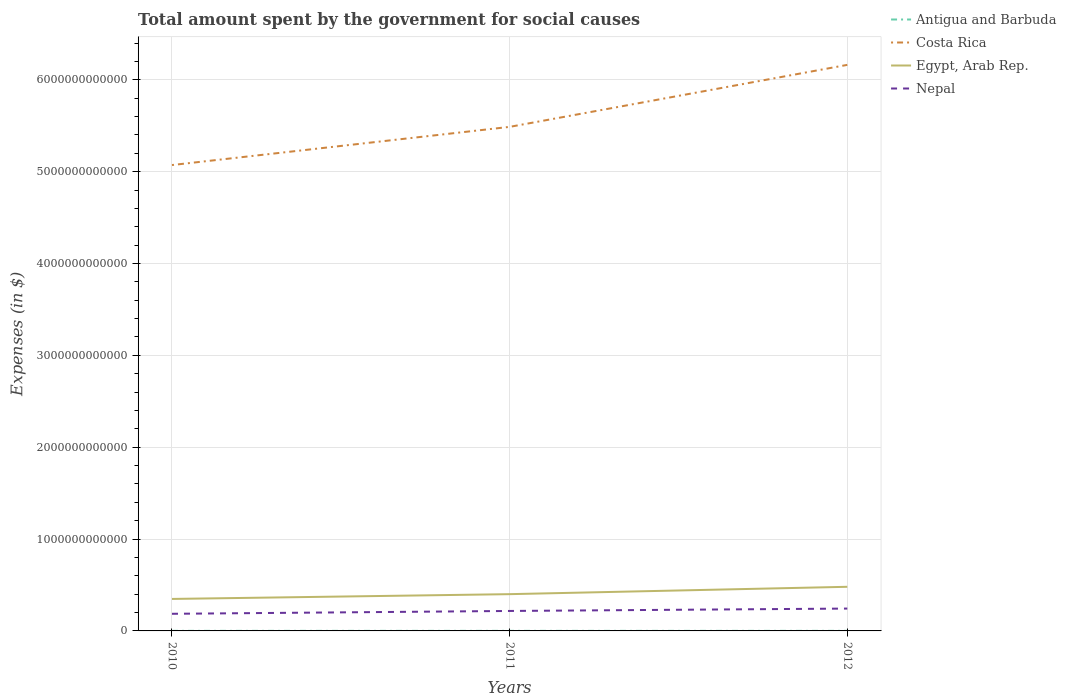Across all years, what is the maximum amount spent for social causes by the government in Antigua and Barbuda?
Provide a short and direct response. 6.72e+08. What is the total amount spent for social causes by the government in Nepal in the graph?
Give a very brief answer. -2.60e+1. What is the difference between the highest and the second highest amount spent for social causes by the government in Nepal?
Ensure brevity in your answer.  5.69e+1. How many lines are there?
Your answer should be compact. 4. How many years are there in the graph?
Provide a succinct answer. 3. What is the difference between two consecutive major ticks on the Y-axis?
Make the answer very short. 1.00e+12. Does the graph contain grids?
Offer a terse response. Yes. Where does the legend appear in the graph?
Keep it short and to the point. Top right. How many legend labels are there?
Offer a terse response. 4. How are the legend labels stacked?
Offer a very short reply. Vertical. What is the title of the graph?
Provide a short and direct response. Total amount spent by the government for social causes. Does "Mauritania" appear as one of the legend labels in the graph?
Ensure brevity in your answer.  No. What is the label or title of the Y-axis?
Keep it short and to the point. Expenses (in $). What is the Expenses (in $) of Antigua and Barbuda in 2010?
Make the answer very short. 6.76e+08. What is the Expenses (in $) in Costa Rica in 2010?
Your response must be concise. 5.07e+12. What is the Expenses (in $) of Egypt, Arab Rep. in 2010?
Provide a succinct answer. 3.48e+11. What is the Expenses (in $) in Nepal in 2010?
Offer a very short reply. 1.86e+11. What is the Expenses (in $) of Antigua and Barbuda in 2011?
Keep it short and to the point. 7.15e+08. What is the Expenses (in $) in Costa Rica in 2011?
Provide a short and direct response. 5.49e+12. What is the Expenses (in $) in Egypt, Arab Rep. in 2011?
Provide a succinct answer. 4.00e+11. What is the Expenses (in $) of Nepal in 2011?
Offer a terse response. 2.17e+11. What is the Expenses (in $) in Antigua and Barbuda in 2012?
Your answer should be very brief. 6.72e+08. What is the Expenses (in $) in Costa Rica in 2012?
Provide a succinct answer. 6.16e+12. What is the Expenses (in $) of Egypt, Arab Rep. in 2012?
Offer a terse response. 4.80e+11. What is the Expenses (in $) of Nepal in 2012?
Provide a short and direct response. 2.43e+11. Across all years, what is the maximum Expenses (in $) in Antigua and Barbuda?
Ensure brevity in your answer.  7.15e+08. Across all years, what is the maximum Expenses (in $) in Costa Rica?
Provide a succinct answer. 6.16e+12. Across all years, what is the maximum Expenses (in $) in Egypt, Arab Rep.?
Your answer should be compact. 4.80e+11. Across all years, what is the maximum Expenses (in $) in Nepal?
Your answer should be compact. 2.43e+11. Across all years, what is the minimum Expenses (in $) in Antigua and Barbuda?
Your answer should be very brief. 6.72e+08. Across all years, what is the minimum Expenses (in $) of Costa Rica?
Provide a short and direct response. 5.07e+12. Across all years, what is the minimum Expenses (in $) in Egypt, Arab Rep.?
Your answer should be very brief. 3.48e+11. Across all years, what is the minimum Expenses (in $) of Nepal?
Give a very brief answer. 1.86e+11. What is the total Expenses (in $) in Antigua and Barbuda in the graph?
Provide a short and direct response. 2.06e+09. What is the total Expenses (in $) in Costa Rica in the graph?
Provide a short and direct response. 1.67e+13. What is the total Expenses (in $) in Egypt, Arab Rep. in the graph?
Offer a terse response. 1.23e+12. What is the total Expenses (in $) in Nepal in the graph?
Provide a short and direct response. 6.47e+11. What is the difference between the Expenses (in $) in Antigua and Barbuda in 2010 and that in 2011?
Give a very brief answer. -3.85e+07. What is the difference between the Expenses (in $) of Costa Rica in 2010 and that in 2011?
Offer a terse response. -4.16e+11. What is the difference between the Expenses (in $) in Egypt, Arab Rep. in 2010 and that in 2011?
Your answer should be very brief. -5.20e+1. What is the difference between the Expenses (in $) in Nepal in 2010 and that in 2011?
Give a very brief answer. -3.08e+1. What is the difference between the Expenses (in $) of Antigua and Barbuda in 2010 and that in 2012?
Provide a succinct answer. 4.70e+06. What is the difference between the Expenses (in $) in Costa Rica in 2010 and that in 2012?
Provide a short and direct response. -1.09e+12. What is the difference between the Expenses (in $) in Egypt, Arab Rep. in 2010 and that in 2012?
Your response must be concise. -1.32e+11. What is the difference between the Expenses (in $) in Nepal in 2010 and that in 2012?
Offer a very short reply. -5.69e+1. What is the difference between the Expenses (in $) of Antigua and Barbuda in 2011 and that in 2012?
Offer a terse response. 4.32e+07. What is the difference between the Expenses (in $) of Costa Rica in 2011 and that in 2012?
Give a very brief answer. -6.75e+11. What is the difference between the Expenses (in $) in Egypt, Arab Rep. in 2011 and that in 2012?
Provide a short and direct response. -8.02e+1. What is the difference between the Expenses (in $) of Nepal in 2011 and that in 2012?
Keep it short and to the point. -2.60e+1. What is the difference between the Expenses (in $) in Antigua and Barbuda in 2010 and the Expenses (in $) in Costa Rica in 2011?
Give a very brief answer. -5.49e+12. What is the difference between the Expenses (in $) in Antigua and Barbuda in 2010 and the Expenses (in $) in Egypt, Arab Rep. in 2011?
Keep it short and to the point. -4.00e+11. What is the difference between the Expenses (in $) of Antigua and Barbuda in 2010 and the Expenses (in $) of Nepal in 2011?
Your response must be concise. -2.17e+11. What is the difference between the Expenses (in $) in Costa Rica in 2010 and the Expenses (in $) in Egypt, Arab Rep. in 2011?
Give a very brief answer. 4.67e+12. What is the difference between the Expenses (in $) of Costa Rica in 2010 and the Expenses (in $) of Nepal in 2011?
Your answer should be very brief. 4.85e+12. What is the difference between the Expenses (in $) of Egypt, Arab Rep. in 2010 and the Expenses (in $) of Nepal in 2011?
Ensure brevity in your answer.  1.31e+11. What is the difference between the Expenses (in $) in Antigua and Barbuda in 2010 and the Expenses (in $) in Costa Rica in 2012?
Offer a very short reply. -6.16e+12. What is the difference between the Expenses (in $) of Antigua and Barbuda in 2010 and the Expenses (in $) of Egypt, Arab Rep. in 2012?
Ensure brevity in your answer.  -4.80e+11. What is the difference between the Expenses (in $) of Antigua and Barbuda in 2010 and the Expenses (in $) of Nepal in 2012?
Offer a terse response. -2.43e+11. What is the difference between the Expenses (in $) of Costa Rica in 2010 and the Expenses (in $) of Egypt, Arab Rep. in 2012?
Your answer should be very brief. 4.59e+12. What is the difference between the Expenses (in $) in Costa Rica in 2010 and the Expenses (in $) in Nepal in 2012?
Make the answer very short. 4.83e+12. What is the difference between the Expenses (in $) in Egypt, Arab Rep. in 2010 and the Expenses (in $) in Nepal in 2012?
Your response must be concise. 1.05e+11. What is the difference between the Expenses (in $) in Antigua and Barbuda in 2011 and the Expenses (in $) in Costa Rica in 2012?
Provide a short and direct response. -6.16e+12. What is the difference between the Expenses (in $) of Antigua and Barbuda in 2011 and the Expenses (in $) of Egypt, Arab Rep. in 2012?
Give a very brief answer. -4.80e+11. What is the difference between the Expenses (in $) in Antigua and Barbuda in 2011 and the Expenses (in $) in Nepal in 2012?
Offer a very short reply. -2.43e+11. What is the difference between the Expenses (in $) of Costa Rica in 2011 and the Expenses (in $) of Egypt, Arab Rep. in 2012?
Provide a short and direct response. 5.01e+12. What is the difference between the Expenses (in $) in Costa Rica in 2011 and the Expenses (in $) in Nepal in 2012?
Ensure brevity in your answer.  5.24e+12. What is the difference between the Expenses (in $) of Egypt, Arab Rep. in 2011 and the Expenses (in $) of Nepal in 2012?
Your answer should be compact. 1.57e+11. What is the average Expenses (in $) of Antigua and Barbuda per year?
Ensure brevity in your answer.  6.87e+08. What is the average Expenses (in $) in Costa Rica per year?
Offer a terse response. 5.57e+12. What is the average Expenses (in $) of Egypt, Arab Rep. per year?
Provide a succinct answer. 4.10e+11. What is the average Expenses (in $) in Nepal per year?
Your answer should be very brief. 2.16e+11. In the year 2010, what is the difference between the Expenses (in $) in Antigua and Barbuda and Expenses (in $) in Costa Rica?
Offer a very short reply. -5.07e+12. In the year 2010, what is the difference between the Expenses (in $) of Antigua and Barbuda and Expenses (in $) of Egypt, Arab Rep.?
Your answer should be compact. -3.48e+11. In the year 2010, what is the difference between the Expenses (in $) of Antigua and Barbuda and Expenses (in $) of Nepal?
Your response must be concise. -1.86e+11. In the year 2010, what is the difference between the Expenses (in $) in Costa Rica and Expenses (in $) in Egypt, Arab Rep.?
Provide a short and direct response. 4.72e+12. In the year 2010, what is the difference between the Expenses (in $) of Costa Rica and Expenses (in $) of Nepal?
Provide a short and direct response. 4.89e+12. In the year 2010, what is the difference between the Expenses (in $) in Egypt, Arab Rep. and Expenses (in $) in Nepal?
Give a very brief answer. 1.62e+11. In the year 2011, what is the difference between the Expenses (in $) in Antigua and Barbuda and Expenses (in $) in Costa Rica?
Offer a terse response. -5.49e+12. In the year 2011, what is the difference between the Expenses (in $) of Antigua and Barbuda and Expenses (in $) of Egypt, Arab Rep.?
Make the answer very short. -4.00e+11. In the year 2011, what is the difference between the Expenses (in $) in Antigua and Barbuda and Expenses (in $) in Nepal?
Your answer should be very brief. -2.17e+11. In the year 2011, what is the difference between the Expenses (in $) of Costa Rica and Expenses (in $) of Egypt, Arab Rep.?
Offer a terse response. 5.09e+12. In the year 2011, what is the difference between the Expenses (in $) in Costa Rica and Expenses (in $) in Nepal?
Provide a short and direct response. 5.27e+12. In the year 2011, what is the difference between the Expenses (in $) of Egypt, Arab Rep. and Expenses (in $) of Nepal?
Your answer should be compact. 1.83e+11. In the year 2012, what is the difference between the Expenses (in $) in Antigua and Barbuda and Expenses (in $) in Costa Rica?
Your response must be concise. -6.16e+12. In the year 2012, what is the difference between the Expenses (in $) in Antigua and Barbuda and Expenses (in $) in Egypt, Arab Rep.?
Give a very brief answer. -4.80e+11. In the year 2012, what is the difference between the Expenses (in $) in Antigua and Barbuda and Expenses (in $) in Nepal?
Your answer should be compact. -2.43e+11. In the year 2012, what is the difference between the Expenses (in $) in Costa Rica and Expenses (in $) in Egypt, Arab Rep.?
Your answer should be very brief. 5.68e+12. In the year 2012, what is the difference between the Expenses (in $) of Costa Rica and Expenses (in $) of Nepal?
Keep it short and to the point. 5.92e+12. In the year 2012, what is the difference between the Expenses (in $) of Egypt, Arab Rep. and Expenses (in $) of Nepal?
Ensure brevity in your answer.  2.37e+11. What is the ratio of the Expenses (in $) of Antigua and Barbuda in 2010 to that in 2011?
Your answer should be compact. 0.95. What is the ratio of the Expenses (in $) of Costa Rica in 2010 to that in 2011?
Ensure brevity in your answer.  0.92. What is the ratio of the Expenses (in $) in Egypt, Arab Rep. in 2010 to that in 2011?
Your response must be concise. 0.87. What is the ratio of the Expenses (in $) in Nepal in 2010 to that in 2011?
Make the answer very short. 0.86. What is the ratio of the Expenses (in $) in Costa Rica in 2010 to that in 2012?
Your answer should be very brief. 0.82. What is the ratio of the Expenses (in $) in Egypt, Arab Rep. in 2010 to that in 2012?
Your response must be concise. 0.72. What is the ratio of the Expenses (in $) of Nepal in 2010 to that in 2012?
Your answer should be compact. 0.77. What is the ratio of the Expenses (in $) of Antigua and Barbuda in 2011 to that in 2012?
Ensure brevity in your answer.  1.06. What is the ratio of the Expenses (in $) in Costa Rica in 2011 to that in 2012?
Offer a terse response. 0.89. What is the ratio of the Expenses (in $) of Egypt, Arab Rep. in 2011 to that in 2012?
Your response must be concise. 0.83. What is the ratio of the Expenses (in $) of Nepal in 2011 to that in 2012?
Give a very brief answer. 0.89. What is the difference between the highest and the second highest Expenses (in $) in Antigua and Barbuda?
Provide a succinct answer. 3.85e+07. What is the difference between the highest and the second highest Expenses (in $) in Costa Rica?
Keep it short and to the point. 6.75e+11. What is the difference between the highest and the second highest Expenses (in $) in Egypt, Arab Rep.?
Give a very brief answer. 8.02e+1. What is the difference between the highest and the second highest Expenses (in $) of Nepal?
Provide a short and direct response. 2.60e+1. What is the difference between the highest and the lowest Expenses (in $) in Antigua and Barbuda?
Provide a succinct answer. 4.32e+07. What is the difference between the highest and the lowest Expenses (in $) in Costa Rica?
Keep it short and to the point. 1.09e+12. What is the difference between the highest and the lowest Expenses (in $) in Egypt, Arab Rep.?
Offer a terse response. 1.32e+11. What is the difference between the highest and the lowest Expenses (in $) of Nepal?
Provide a short and direct response. 5.69e+1. 